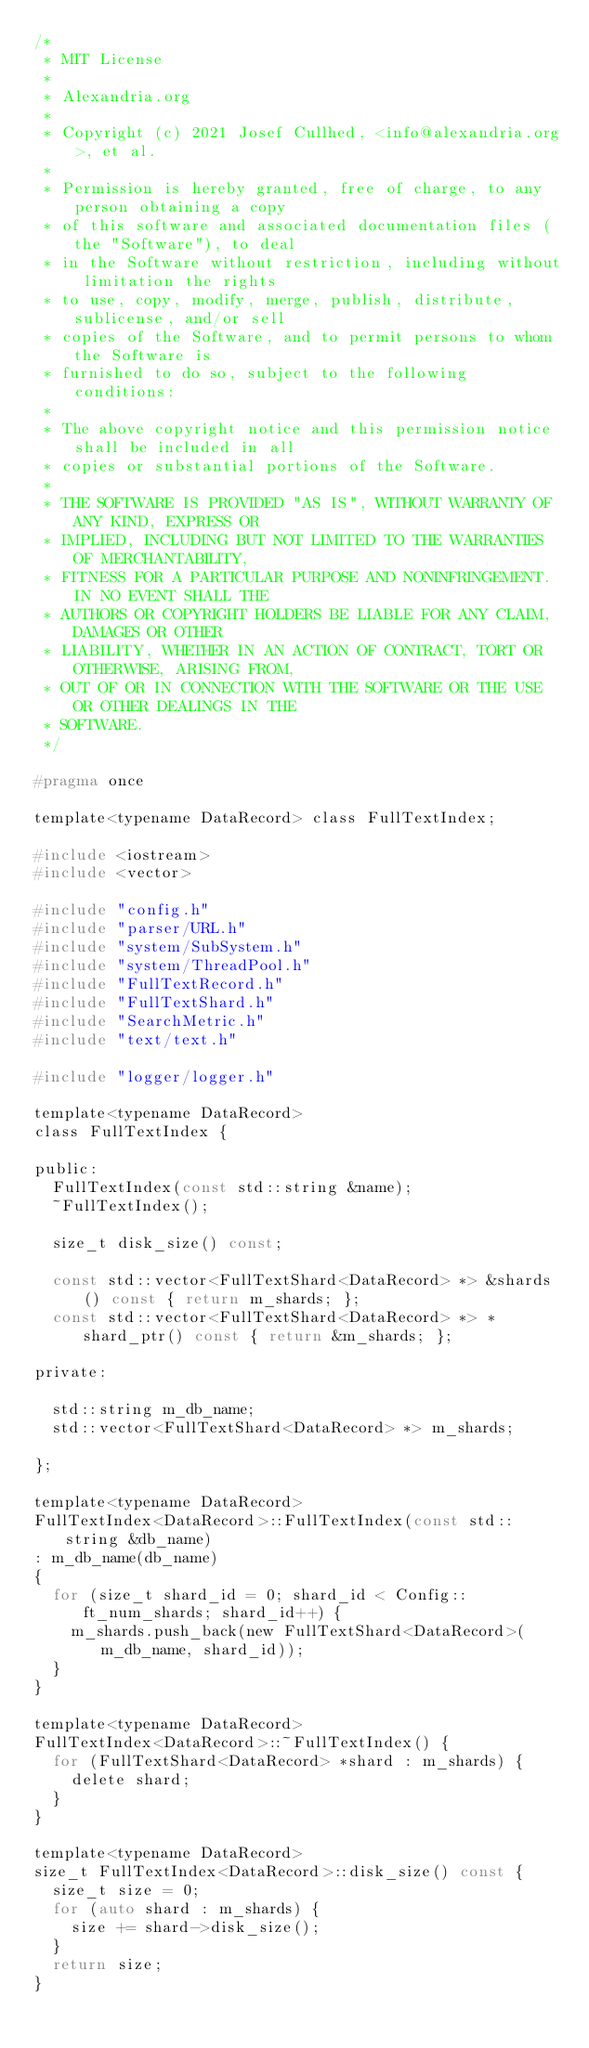<code> <loc_0><loc_0><loc_500><loc_500><_C_>/*
 * MIT License
 *
 * Alexandria.org
 *
 * Copyright (c) 2021 Josef Cullhed, <info@alexandria.org>, et al.
 *
 * Permission is hereby granted, free of charge, to any person obtaining a copy
 * of this software and associated documentation files (the "Software"), to deal
 * in the Software without restriction, including without limitation the rights
 * to use, copy, modify, merge, publish, distribute, sublicense, and/or sell
 * copies of the Software, and to permit persons to whom the Software is
 * furnished to do so, subject to the following conditions:
 * 
 * The above copyright notice and this permission notice shall be included in all
 * copies or substantial portions of the Software.
 * 
 * THE SOFTWARE IS PROVIDED "AS IS", WITHOUT WARRANTY OF ANY KIND, EXPRESS OR
 * IMPLIED, INCLUDING BUT NOT LIMITED TO THE WARRANTIES OF MERCHANTABILITY,
 * FITNESS FOR A PARTICULAR PURPOSE AND NONINFRINGEMENT. IN NO EVENT SHALL THE
 * AUTHORS OR COPYRIGHT HOLDERS BE LIABLE FOR ANY CLAIM, DAMAGES OR OTHER
 * LIABILITY, WHETHER IN AN ACTION OF CONTRACT, TORT OR OTHERWISE, ARISING FROM,
 * OUT OF OR IN CONNECTION WITH THE SOFTWARE OR THE USE OR OTHER DEALINGS IN THE
 * SOFTWARE.
 */

#pragma once

template<typename DataRecord> class FullTextIndex;

#include <iostream>
#include <vector>

#include "config.h"
#include "parser/URL.h"
#include "system/SubSystem.h"
#include "system/ThreadPool.h"
#include "FullTextRecord.h"
#include "FullTextShard.h"
#include "SearchMetric.h"
#include "text/text.h"

#include "logger/logger.h"

template<typename DataRecord>
class FullTextIndex {

public:
	FullTextIndex(const std::string &name);
	~FullTextIndex();

	size_t disk_size() const;

	const std::vector<FullTextShard<DataRecord> *> &shards() const { return m_shards; };
	const std::vector<FullTextShard<DataRecord> *> *shard_ptr() const { return &m_shards; };

private:

	std::string m_db_name;
	std::vector<FullTextShard<DataRecord> *> m_shards;

};

template<typename DataRecord>
FullTextIndex<DataRecord>::FullTextIndex(const std::string &db_name)
: m_db_name(db_name)
{
	for (size_t shard_id = 0; shard_id < Config::ft_num_shards; shard_id++) {
		m_shards.push_back(new FullTextShard<DataRecord>(m_db_name, shard_id));
	}
}

template<typename DataRecord>
FullTextIndex<DataRecord>::~FullTextIndex() {
	for (FullTextShard<DataRecord> *shard : m_shards) {
		delete shard;
	}
}

template<typename DataRecord>
size_t FullTextIndex<DataRecord>::disk_size() const {
	size_t size = 0;
	for (auto shard : m_shards) {
		size += shard->disk_size();
	}
	return size;
}

</code> 